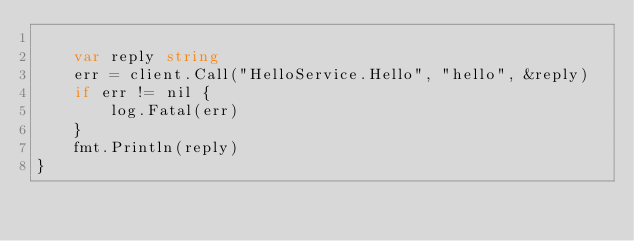Convert code to text. <code><loc_0><loc_0><loc_500><loc_500><_Go_>
	var reply string
	err = client.Call("HelloService.Hello", "hello", &reply)
	if err != nil {
		log.Fatal(err)
	}
	fmt.Println(reply)
}
</code> 